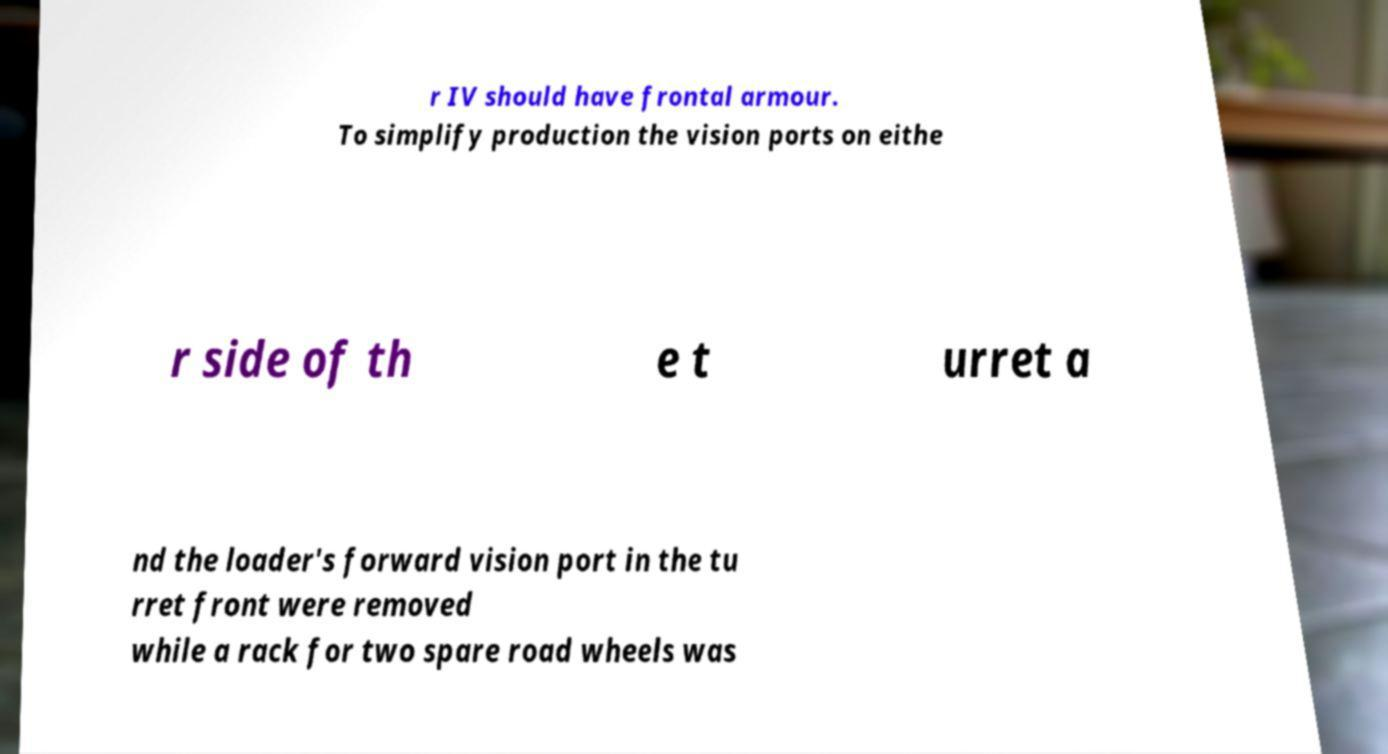Can you accurately transcribe the text from the provided image for me? r IV should have frontal armour. To simplify production the vision ports on eithe r side of th e t urret a nd the loader's forward vision port in the tu rret front were removed while a rack for two spare road wheels was 